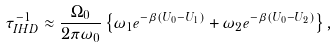<formula> <loc_0><loc_0><loc_500><loc_500>\tau _ { I H D } ^ { - 1 } \approx \frac { \Omega _ { 0 } } { 2 \pi \omega _ { 0 } } \left \{ \omega _ { 1 } e ^ { - \beta ( U _ { 0 } - U _ { 1 } ) } + \omega _ { 2 } e ^ { - \beta ( U _ { 0 } - U _ { 2 } ) } \right \} ,</formula> 